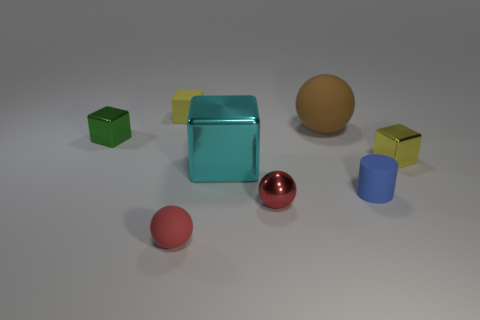If this were a scene from a child's playroom, what might be missing? If this image represented a child's playroom, we might expect to see additional elements such as toy figurines, building blocks with letters or numbers, perhaps some drawings or paintings, and maybe a toy chest or shelves in the background to suggest a more lived-in and personalized space. 